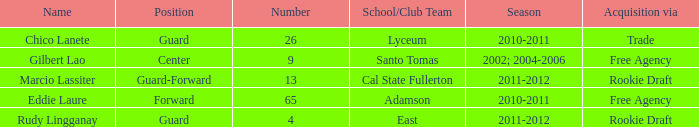In which season was marcio lassiter active? 2011-2012. 